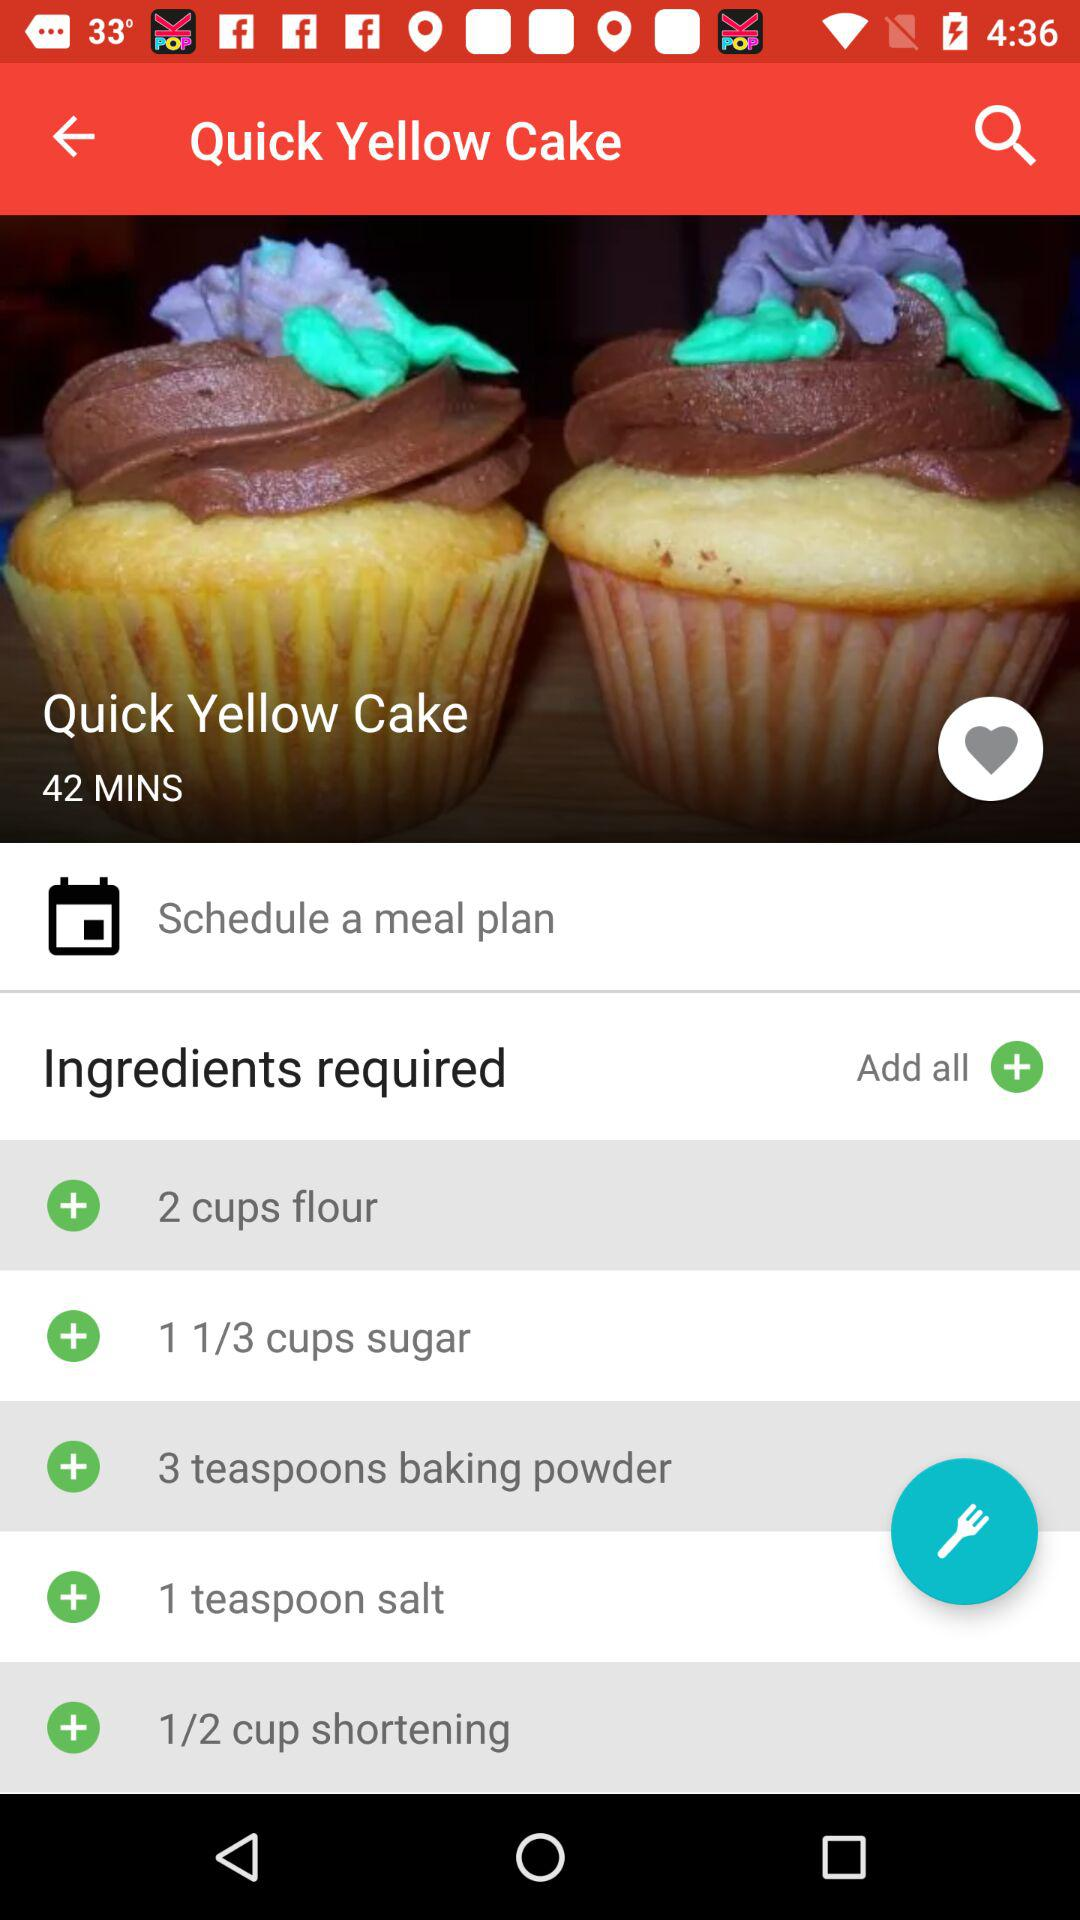How much time duration is there? The time duration is 42 minutes. 